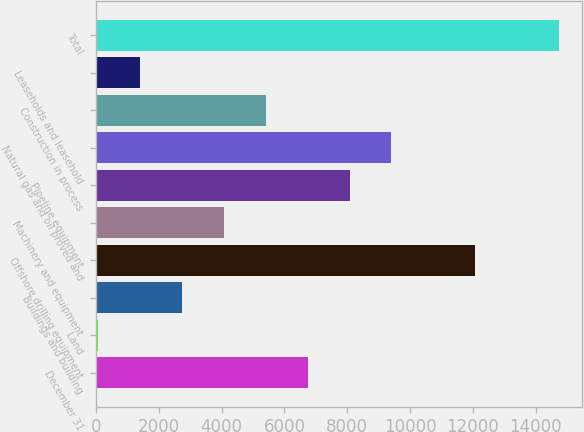Convert chart. <chart><loc_0><loc_0><loc_500><loc_500><bar_chart><fcel>December 31<fcel>Land<fcel>Buildings and building<fcel>Offshore drilling equipment<fcel>Machinery and equipment<fcel>Pipeline equipment<fcel>Natural gas and oil proved and<fcel>Construction in process<fcel>Leaseholds and leasehold<fcel>Total<nl><fcel>6739.5<fcel>70<fcel>2737.8<fcel>12075.1<fcel>4071.7<fcel>8073.4<fcel>9407.3<fcel>5405.6<fcel>1403.9<fcel>14742.9<nl></chart> 